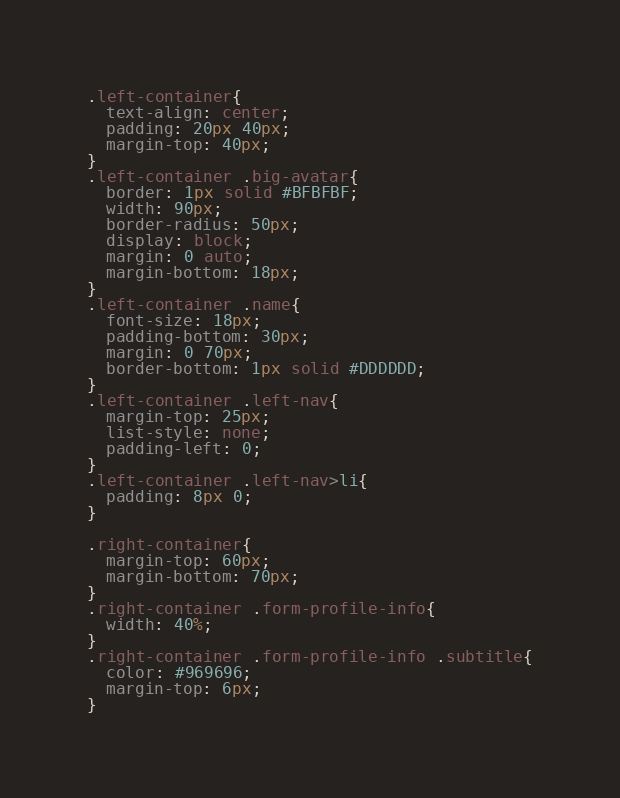Convert code to text. <code><loc_0><loc_0><loc_500><loc_500><_CSS_>.left-container{
  text-align: center;
  padding: 20px 40px;
  margin-top: 40px;
}
.left-container .big-avatar{
  border: 1px solid #BFBFBF;
  width: 90px;
  border-radius: 50px;
  display: block;
  margin: 0 auto;
  margin-bottom: 18px;
}
.left-container .name{
  font-size: 18px;
  padding-bottom: 30px;
  margin: 0 70px;
  border-bottom: 1px solid #DDDDDD;
}
.left-container .left-nav{
  margin-top: 25px;
  list-style: none;
  padding-left: 0;
}
.left-container .left-nav>li{
  padding: 8px 0;
}

.right-container{
  margin-top: 60px;
  margin-bottom: 70px;
}
.right-container .form-profile-info{
  width: 40%;
}
.right-container .form-profile-info .subtitle{
  color: #969696;
  margin-top: 6px;
}</code> 